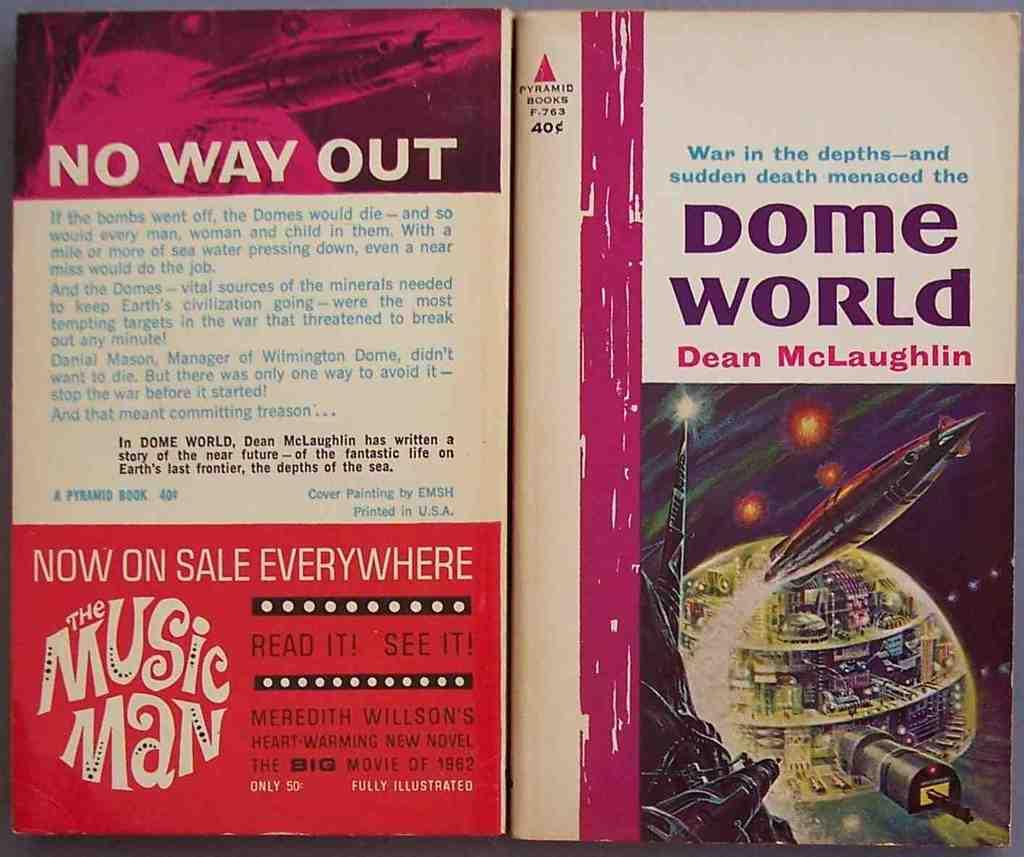<image>
Render a clear and concise summary of the photo. The book Dome World is open and upside down with front and back covers visible. 